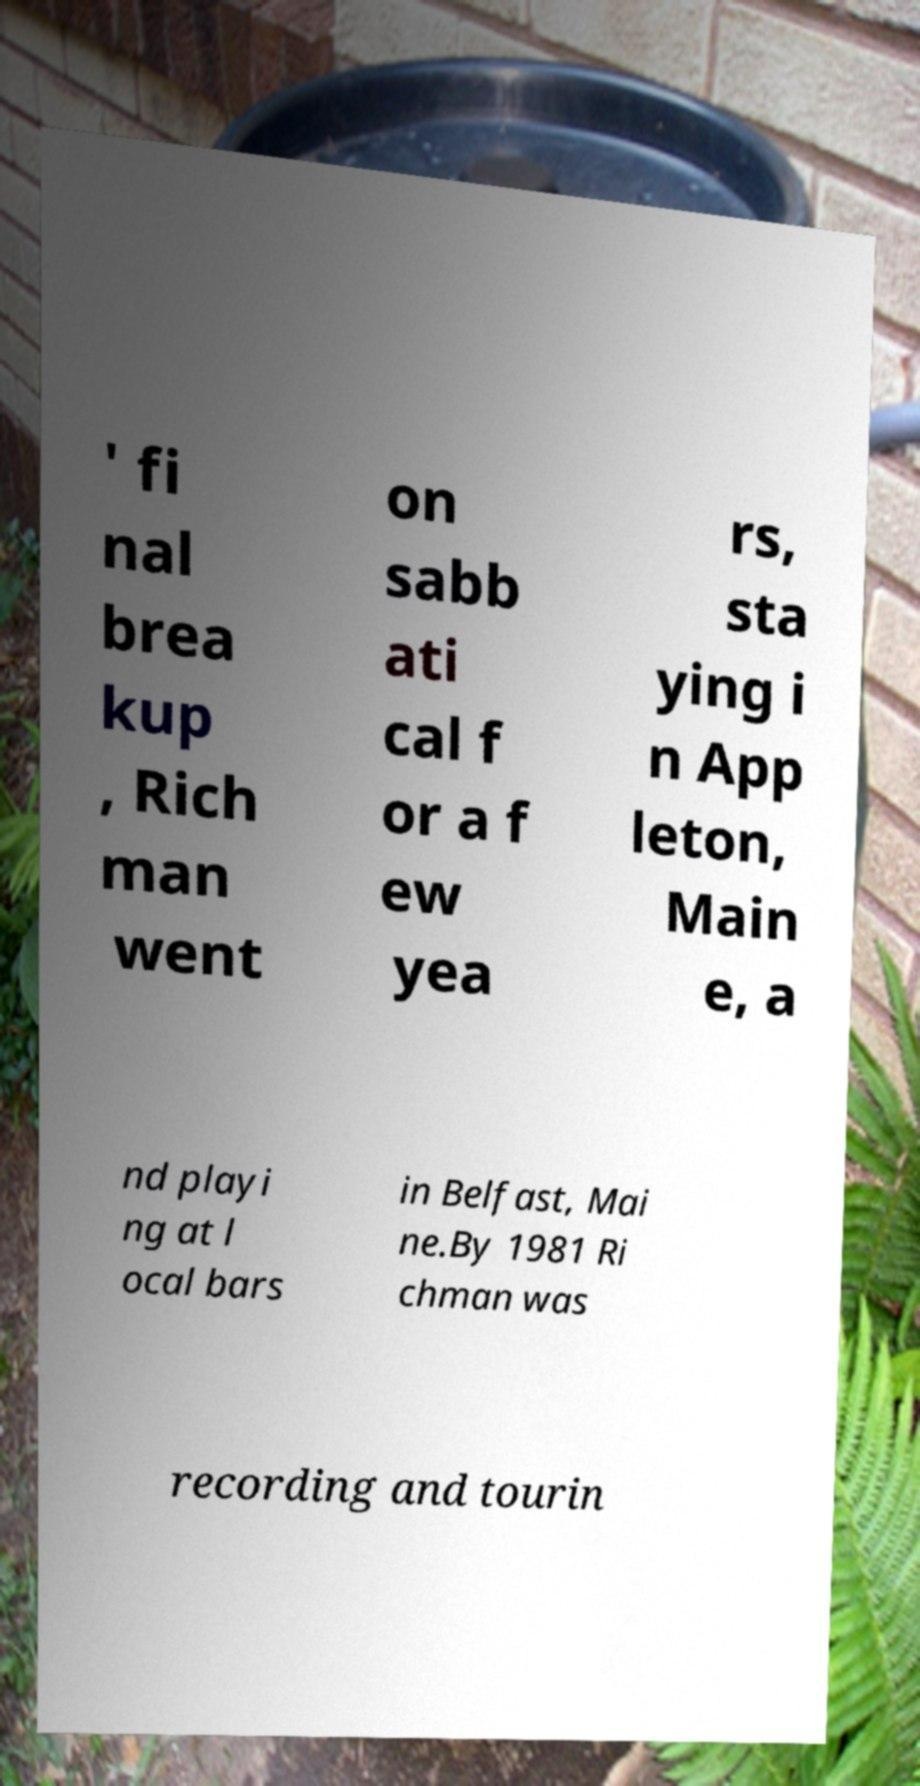Please identify and transcribe the text found in this image. ' fi nal brea kup , Rich man went on sabb ati cal f or a f ew yea rs, sta ying i n App leton, Main e, a nd playi ng at l ocal bars in Belfast, Mai ne.By 1981 Ri chman was recording and tourin 